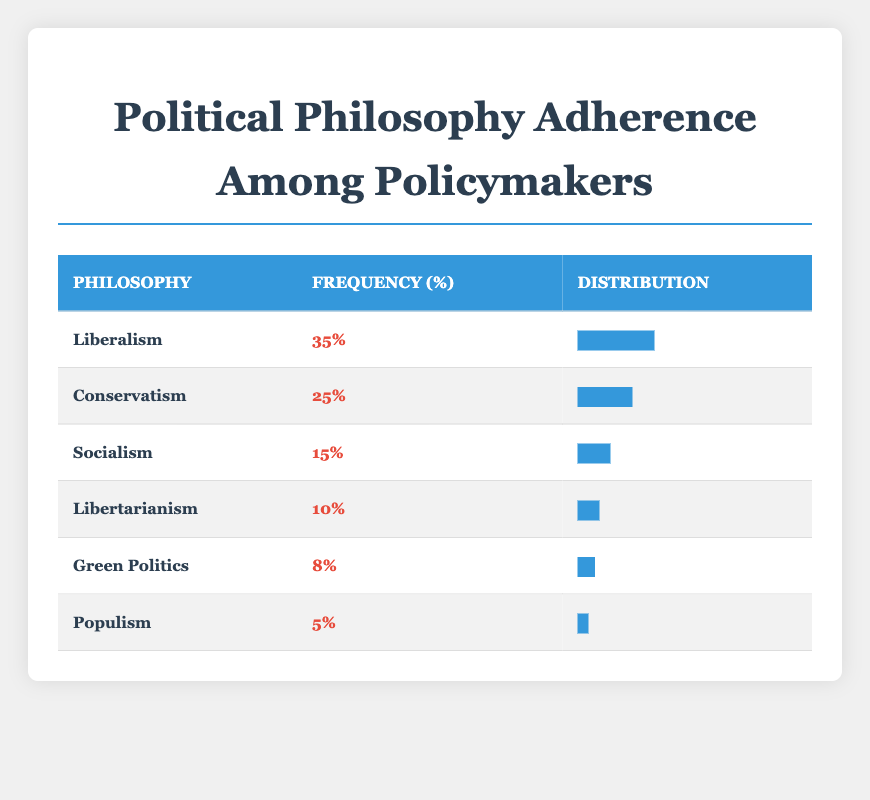What is the frequency of adherence to Liberalism among policymakers? The table shows that the frequency of adherence to Liberalism is listed directly under the "Frequency" column. In this case, it is 35%.
Answer: 35% How many policymakers adhere to Socialism? The frequency for Socialism is directly provided in the table, which states that 15 policymakers adhere to this philosophy.
Answer: 15 Which political philosophy has the lowest adherence frequency? The table lists Populism with a frequency of 5%, which is the lowest compared to all other philosophies listed.
Answer: Populism What is the total frequency of all listed political philosophies? To find the total, we sum the frequencies from each row: 35 (Liberalism) + 25 (Conservatism) + 15 (Socialism) + 10 (Libertarianism) + 8 (Green Politics) + 5 (Populism) = 98.
Answer: 98 What percentage of policymakers adhere to either Liberalism or Conservatism? We first find the frequencies of Liberalism (35%) and Conservatism (25%). Adding these frequencies gives us 35% + 25% = 60%.
Answer: 60% Is the frequency of adherence to Green Politics greater than that of Libertarianism? The table indicates that the frequency for Green Politics is 8%, while Libertarianism has a frequency of 10%. Since 8% is less than 10%, the answer is no.
Answer: No How many more policymakers adhere to Conservatism compared to Populism? We find the frequencies: Conservatism has 25 and Populism has 5. The difference is 25 - 5 = 20.
Answer: 20 What is the combined frequency of adherence to Socialism and Green Politics? We add the frequency of Socialism (15) to Green Politics (8), resulting in 15 + 8 = 23.
Answer: 23 Are there more policymakers adhering to Liberalism than to Socialism combined with Libertarianism? We check the frequencies: Liberalism is 35%, and together, Socialism (15%) and Libertarianism (10%) total 25%. Since 35% is greater than 25%, the answer is yes.
Answer: Yes 